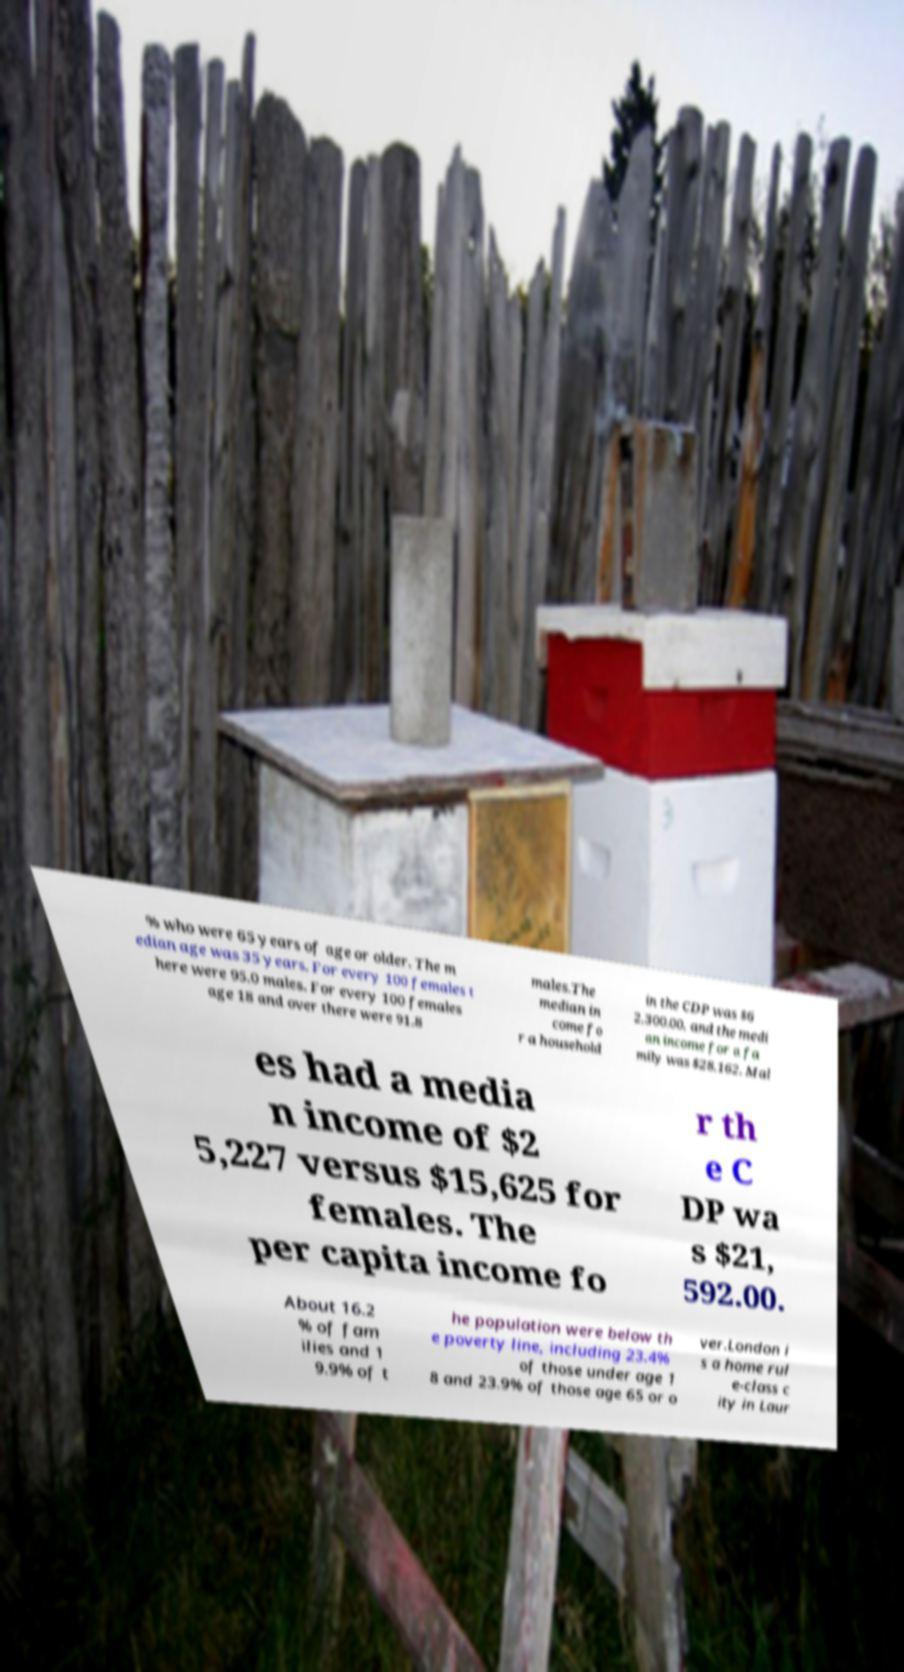Can you read and provide the text displayed in the image?This photo seems to have some interesting text. Can you extract and type it out for me? % who were 65 years of age or older. The m edian age was 35 years. For every 100 females t here were 95.0 males. For every 100 females age 18 and over there were 91.8 males.The median in come fo r a household in the CDP was $6 2,300.00, and the medi an income for a fa mily was $28,162. Mal es had a media n income of $2 5,227 versus $15,625 for females. The per capita income fo r th e C DP wa s $21, 592.00. About 16.2 % of fam ilies and 1 9.9% of t he population were below th e poverty line, including 23.4% of those under age 1 8 and 23.9% of those age 65 or o ver.London i s a home rul e-class c ity in Laur 